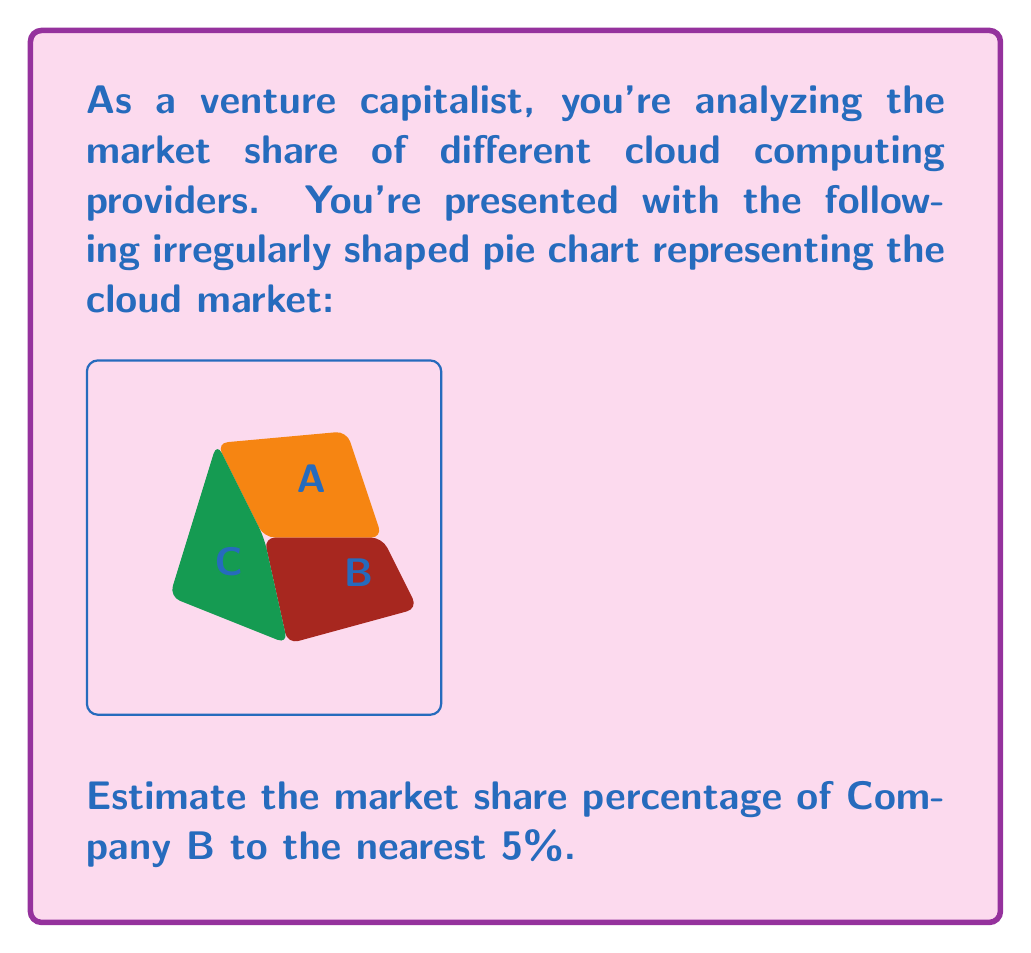Teach me how to tackle this problem. To estimate the market share percentage of Company B, we need to follow these steps:

1) First, visually divide the entire pie chart into quarters (25% each).

2) Observe that Company B's slice occupies roughly 1.5 quarters of the pie.

3) Calculate the estimated percentage:
   $1.5 \text{ quarters} \times 25\% = 37.5\%$

4) Round to the nearest 5%:
   $37.5\%$ rounds to $40\%$

This method of estimation is particularly useful in venture capital when quick, approximate assessments are needed. While not precise, it provides a reasonable estimate for decision-making in fast-paced investment scenarios.
Answer: 40% 